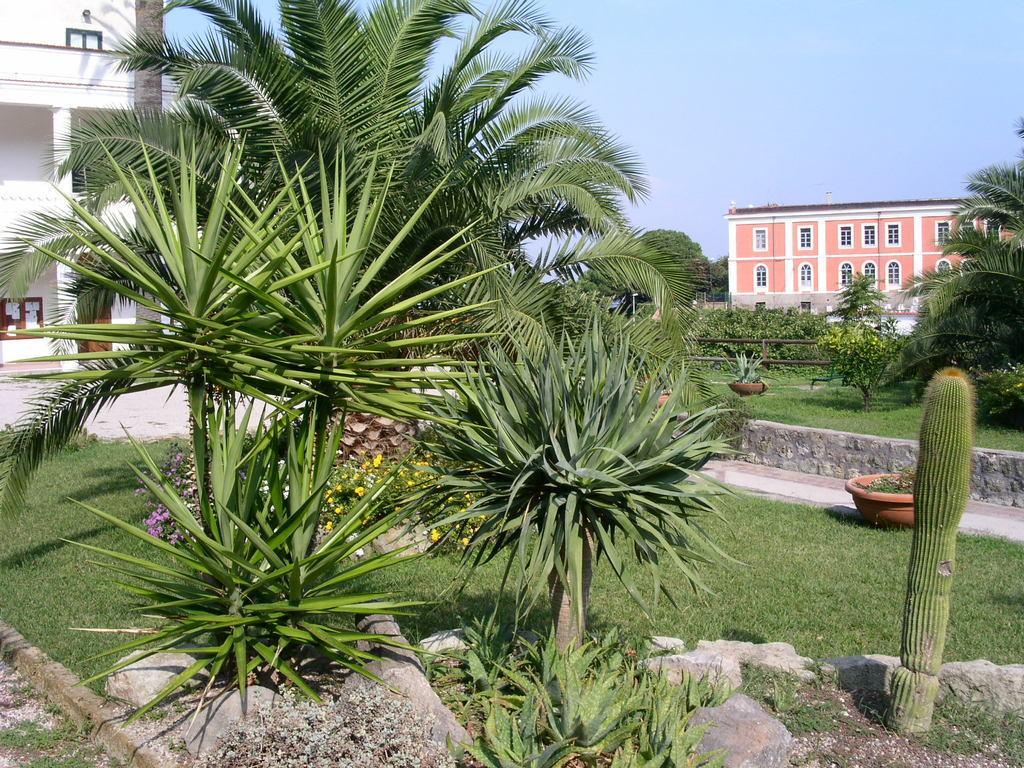How would you summarize this image in a sentence or two? In the foreground of the picture I can see the trees. I can see the flowering plants, green grass and a flower pot. In the background, I can see the buildings and trees. There are clouds in the sky. 